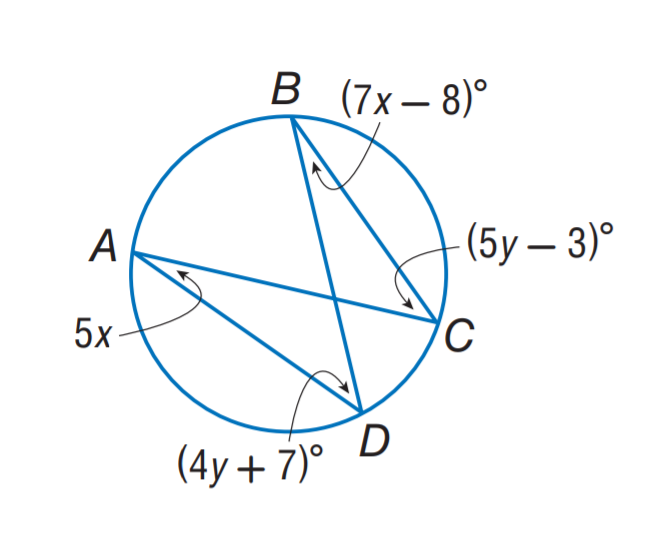Answer the mathemtical geometry problem and directly provide the correct option letter.
Question: Find m \angle A.
Choices: A: 17 B: 20 C: 33 D: 47 B 